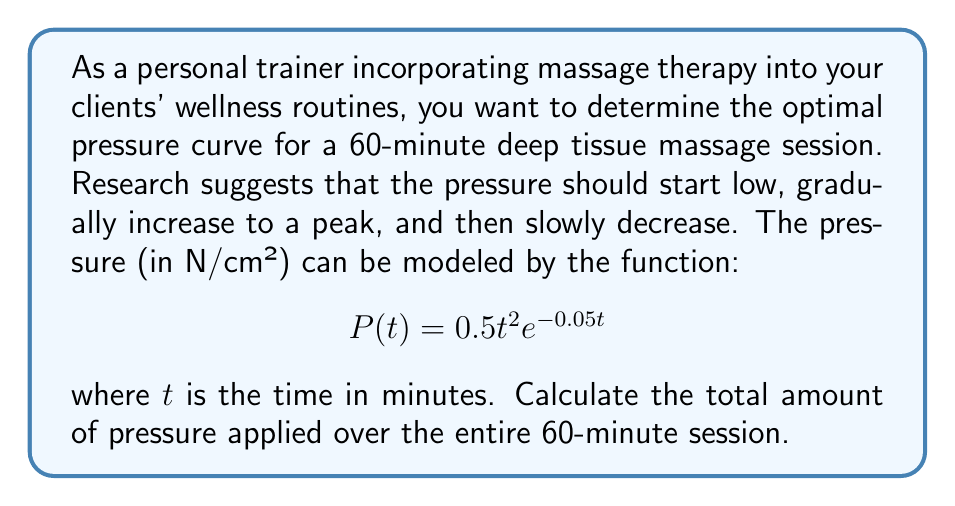Can you solve this math problem? To solve this problem, we need to integrate the pressure function over the entire time interval. Here's a step-by-step approach:

1) The total pressure applied is represented by the area under the curve of $P(t)$ from $t=0$ to $t=60$. This can be calculated using a definite integral:

   $$\int_0^{60} P(t) dt = \int_0^{60} 0.5t^2e^{-0.05t} dt$$

2) This integral doesn't have an elementary antiderivative, so we need to use integration by parts twice. Let $u = t^2$ and $dv = e^{-0.05t}dt$.

3) First application of integration by parts:
   $$\int t^2e^{-0.05t} dt = -20t^2e^{-0.05t} + \int 40te^{-0.05t} dt$$

4) Second application of integration by parts (let $u = t$ and $dv = e^{-0.05t}dt$):
   $$\int 40te^{-0.05t} dt = -800te^{-0.05t} + \int 800e^{-0.05t} dt$$

5) Combining these results:
   $$\int t^2e^{-0.05t} dt = -20t^2e^{-0.05t} - 800te^{-0.05t} - 16000e^{-0.05t} + C$$

6) Now we can evaluate the definite integral:

   $$[(-20t^2e^{-0.05t} - 800te^{-0.05t} - 16000e^{-0.05t})]_0^{60}$$

7) Evaluating at $t=60$ and $t=0$:
   $$(-20(60)^2e^{-3} - 800(60)e^{-3} - 16000e^{-3}) - (-20(0)^2e^0 - 800(0)e^0 - 16000e^0)$$

8) Simplifying:
   $$(-72000e^{-3} - 48000e^{-3} - 16000e^{-3}) - (-16000)$$
   $$= -136000e^{-3} + 16000$$
   $$\approx 15754.07$$

9) Finally, multiply by 0.5 as per the original function:
   $$0.5 * 15754.07 \approx 7877.04$$
Answer: The total amount of pressure applied over the 60-minute deep tissue massage session is approximately 7877.04 N·min/cm². 